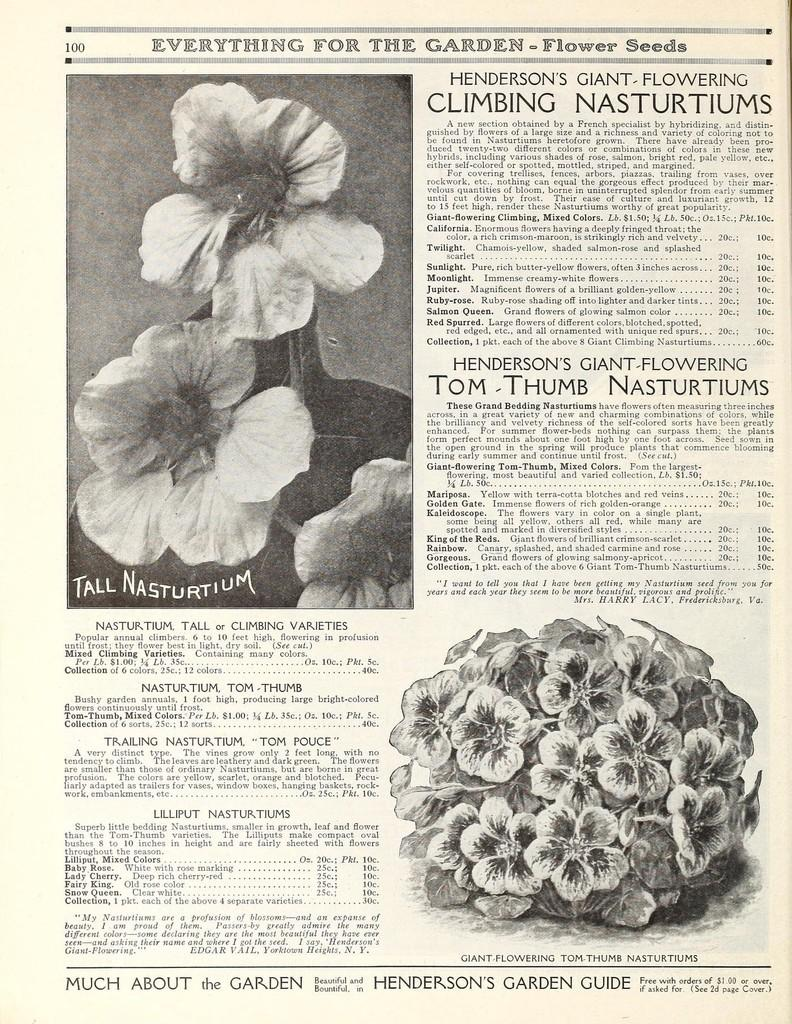What type of photos are present in the image? The image contains photos of plants with flowers. What other elements can be found in the image besides the photos? There are paragraphs in the image. How can the reader identify the specific page of the document? The paper has a page number. What is the servant's opinion about the honey in the image? There is no servant or honey present in the image, so it is not possible to answer that question. 